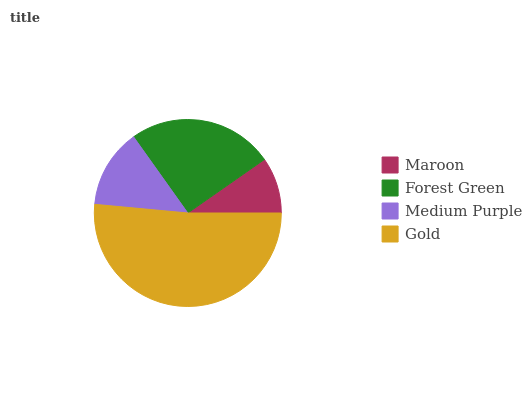Is Maroon the minimum?
Answer yes or no. Yes. Is Gold the maximum?
Answer yes or no. Yes. Is Forest Green the minimum?
Answer yes or no. No. Is Forest Green the maximum?
Answer yes or no. No. Is Forest Green greater than Maroon?
Answer yes or no. Yes. Is Maroon less than Forest Green?
Answer yes or no. Yes. Is Maroon greater than Forest Green?
Answer yes or no. No. Is Forest Green less than Maroon?
Answer yes or no. No. Is Forest Green the high median?
Answer yes or no. Yes. Is Medium Purple the low median?
Answer yes or no. Yes. Is Maroon the high median?
Answer yes or no. No. Is Maroon the low median?
Answer yes or no. No. 